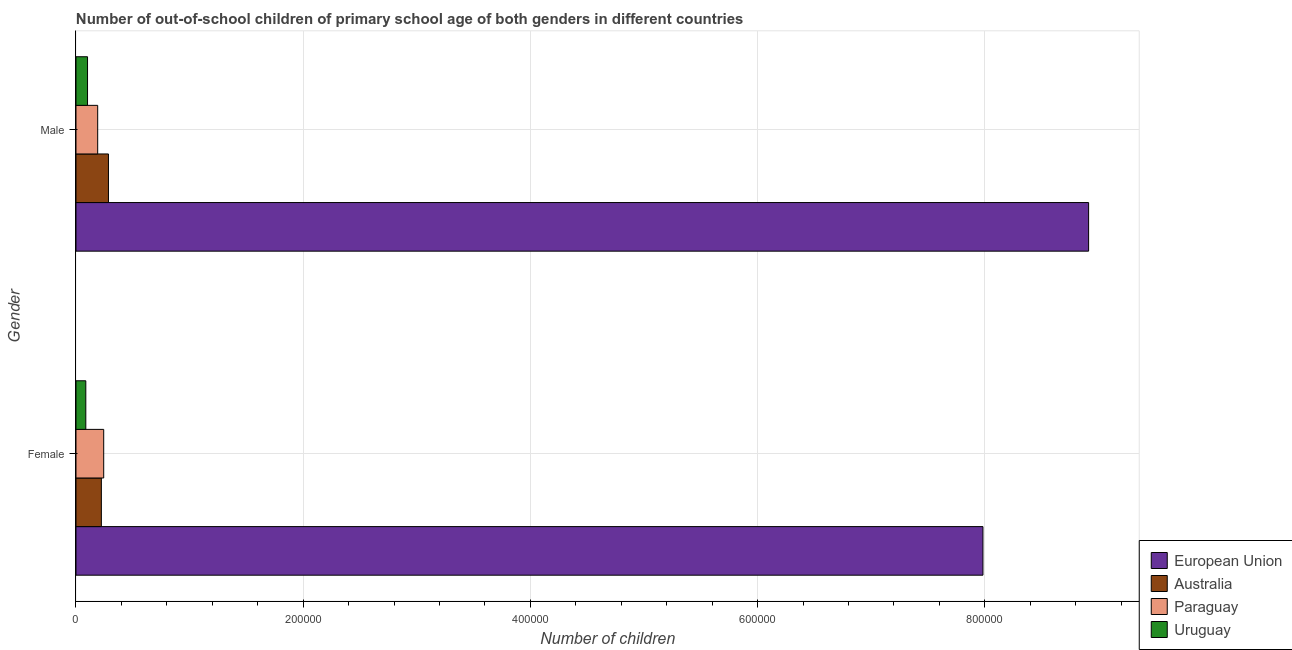How many different coloured bars are there?
Keep it short and to the point. 4. Are the number of bars per tick equal to the number of legend labels?
Make the answer very short. Yes. How many bars are there on the 2nd tick from the bottom?
Offer a very short reply. 4. What is the number of female out-of-school students in European Union?
Offer a terse response. 7.98e+05. Across all countries, what is the maximum number of male out-of-school students?
Your answer should be very brief. 8.91e+05. Across all countries, what is the minimum number of male out-of-school students?
Ensure brevity in your answer.  1.02e+04. In which country was the number of female out-of-school students minimum?
Give a very brief answer. Uruguay. What is the total number of female out-of-school students in the graph?
Make the answer very short. 8.54e+05. What is the difference between the number of female out-of-school students in Paraguay and that in Australia?
Ensure brevity in your answer.  2065. What is the difference between the number of male out-of-school students in Australia and the number of female out-of-school students in Paraguay?
Ensure brevity in your answer.  4180. What is the average number of male out-of-school students per country?
Provide a succinct answer. 2.37e+05. What is the difference between the number of male out-of-school students and number of female out-of-school students in Uruguay?
Offer a terse response. 1510. What is the ratio of the number of female out-of-school students in European Union to that in Uruguay?
Make the answer very short. 92.28. Is the number of female out-of-school students in Australia less than that in Paraguay?
Provide a succinct answer. Yes. What does the 2nd bar from the top in Male represents?
Your answer should be very brief. Paraguay. How many bars are there?
Your answer should be very brief. 8. Are all the bars in the graph horizontal?
Offer a terse response. Yes. What is the difference between two consecutive major ticks on the X-axis?
Offer a terse response. 2.00e+05. Are the values on the major ticks of X-axis written in scientific E-notation?
Your answer should be very brief. No. Does the graph contain any zero values?
Give a very brief answer. No. Where does the legend appear in the graph?
Provide a succinct answer. Bottom right. How many legend labels are there?
Ensure brevity in your answer.  4. How are the legend labels stacked?
Keep it short and to the point. Vertical. What is the title of the graph?
Your answer should be very brief. Number of out-of-school children of primary school age of both genders in different countries. Does "Papua New Guinea" appear as one of the legend labels in the graph?
Make the answer very short. No. What is the label or title of the X-axis?
Provide a short and direct response. Number of children. What is the label or title of the Y-axis?
Your response must be concise. Gender. What is the Number of children of European Union in Female?
Offer a terse response. 7.98e+05. What is the Number of children in Australia in Female?
Offer a very short reply. 2.23e+04. What is the Number of children of Paraguay in Female?
Your answer should be very brief. 2.44e+04. What is the Number of children in Uruguay in Female?
Make the answer very short. 8652. What is the Number of children in European Union in Male?
Ensure brevity in your answer.  8.91e+05. What is the Number of children of Australia in Male?
Your response must be concise. 2.86e+04. What is the Number of children of Paraguay in Male?
Offer a very short reply. 1.91e+04. What is the Number of children in Uruguay in Male?
Provide a short and direct response. 1.02e+04. Across all Gender, what is the maximum Number of children in European Union?
Make the answer very short. 8.91e+05. Across all Gender, what is the maximum Number of children in Australia?
Provide a succinct answer. 2.86e+04. Across all Gender, what is the maximum Number of children in Paraguay?
Keep it short and to the point. 2.44e+04. Across all Gender, what is the maximum Number of children in Uruguay?
Offer a very short reply. 1.02e+04. Across all Gender, what is the minimum Number of children in European Union?
Offer a terse response. 7.98e+05. Across all Gender, what is the minimum Number of children in Australia?
Offer a very short reply. 2.23e+04. Across all Gender, what is the minimum Number of children in Paraguay?
Provide a succinct answer. 1.91e+04. Across all Gender, what is the minimum Number of children in Uruguay?
Your answer should be very brief. 8652. What is the total Number of children in European Union in the graph?
Give a very brief answer. 1.69e+06. What is the total Number of children of Australia in the graph?
Give a very brief answer. 5.09e+04. What is the total Number of children of Paraguay in the graph?
Your answer should be very brief. 4.35e+04. What is the total Number of children of Uruguay in the graph?
Your answer should be compact. 1.88e+04. What is the difference between the Number of children of European Union in Female and that in Male?
Your answer should be compact. -9.30e+04. What is the difference between the Number of children of Australia in Female and that in Male?
Make the answer very short. -6245. What is the difference between the Number of children of Paraguay in Female and that in Male?
Give a very brief answer. 5286. What is the difference between the Number of children of Uruguay in Female and that in Male?
Make the answer very short. -1510. What is the difference between the Number of children in European Union in Female and the Number of children in Australia in Male?
Your response must be concise. 7.70e+05. What is the difference between the Number of children in European Union in Female and the Number of children in Paraguay in Male?
Ensure brevity in your answer.  7.79e+05. What is the difference between the Number of children of European Union in Female and the Number of children of Uruguay in Male?
Make the answer very short. 7.88e+05. What is the difference between the Number of children in Australia in Female and the Number of children in Paraguay in Male?
Give a very brief answer. 3221. What is the difference between the Number of children of Australia in Female and the Number of children of Uruguay in Male?
Keep it short and to the point. 1.22e+04. What is the difference between the Number of children of Paraguay in Female and the Number of children of Uruguay in Male?
Your response must be concise. 1.42e+04. What is the average Number of children in European Union per Gender?
Provide a succinct answer. 8.45e+05. What is the average Number of children in Australia per Gender?
Offer a terse response. 2.54e+04. What is the average Number of children in Paraguay per Gender?
Your answer should be very brief. 2.17e+04. What is the average Number of children in Uruguay per Gender?
Provide a short and direct response. 9407. What is the difference between the Number of children in European Union and Number of children in Australia in Female?
Offer a terse response. 7.76e+05. What is the difference between the Number of children in European Union and Number of children in Paraguay in Female?
Ensure brevity in your answer.  7.74e+05. What is the difference between the Number of children of European Union and Number of children of Uruguay in Female?
Ensure brevity in your answer.  7.90e+05. What is the difference between the Number of children of Australia and Number of children of Paraguay in Female?
Your response must be concise. -2065. What is the difference between the Number of children of Australia and Number of children of Uruguay in Female?
Provide a succinct answer. 1.37e+04. What is the difference between the Number of children of Paraguay and Number of children of Uruguay in Female?
Give a very brief answer. 1.57e+04. What is the difference between the Number of children in European Union and Number of children in Australia in Male?
Ensure brevity in your answer.  8.63e+05. What is the difference between the Number of children of European Union and Number of children of Paraguay in Male?
Give a very brief answer. 8.72e+05. What is the difference between the Number of children in European Union and Number of children in Uruguay in Male?
Offer a terse response. 8.81e+05. What is the difference between the Number of children of Australia and Number of children of Paraguay in Male?
Offer a very short reply. 9466. What is the difference between the Number of children in Australia and Number of children in Uruguay in Male?
Your answer should be compact. 1.84e+04. What is the difference between the Number of children of Paraguay and Number of children of Uruguay in Male?
Offer a very short reply. 8944. What is the ratio of the Number of children in European Union in Female to that in Male?
Your answer should be compact. 0.9. What is the ratio of the Number of children of Australia in Female to that in Male?
Give a very brief answer. 0.78. What is the ratio of the Number of children in Paraguay in Female to that in Male?
Offer a terse response. 1.28. What is the ratio of the Number of children in Uruguay in Female to that in Male?
Your response must be concise. 0.85. What is the difference between the highest and the second highest Number of children in European Union?
Your answer should be very brief. 9.30e+04. What is the difference between the highest and the second highest Number of children in Australia?
Keep it short and to the point. 6245. What is the difference between the highest and the second highest Number of children of Paraguay?
Ensure brevity in your answer.  5286. What is the difference between the highest and the second highest Number of children of Uruguay?
Ensure brevity in your answer.  1510. What is the difference between the highest and the lowest Number of children of European Union?
Ensure brevity in your answer.  9.30e+04. What is the difference between the highest and the lowest Number of children of Australia?
Keep it short and to the point. 6245. What is the difference between the highest and the lowest Number of children in Paraguay?
Your answer should be very brief. 5286. What is the difference between the highest and the lowest Number of children in Uruguay?
Keep it short and to the point. 1510. 